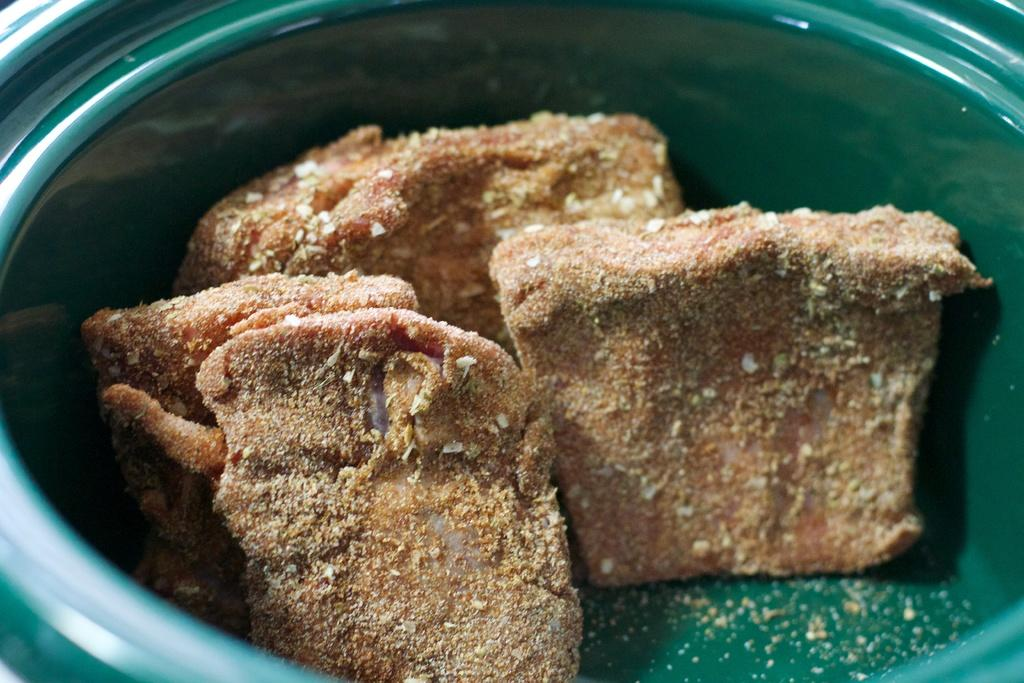What color is the bowl in the image? The bowl in the image is green. What type of food items are in the bowl? The bowl contains brown food items. How many bikes are parked next to the green bowl in the image? There are no bikes present in the image; it only features a green bowl with brown food items. 